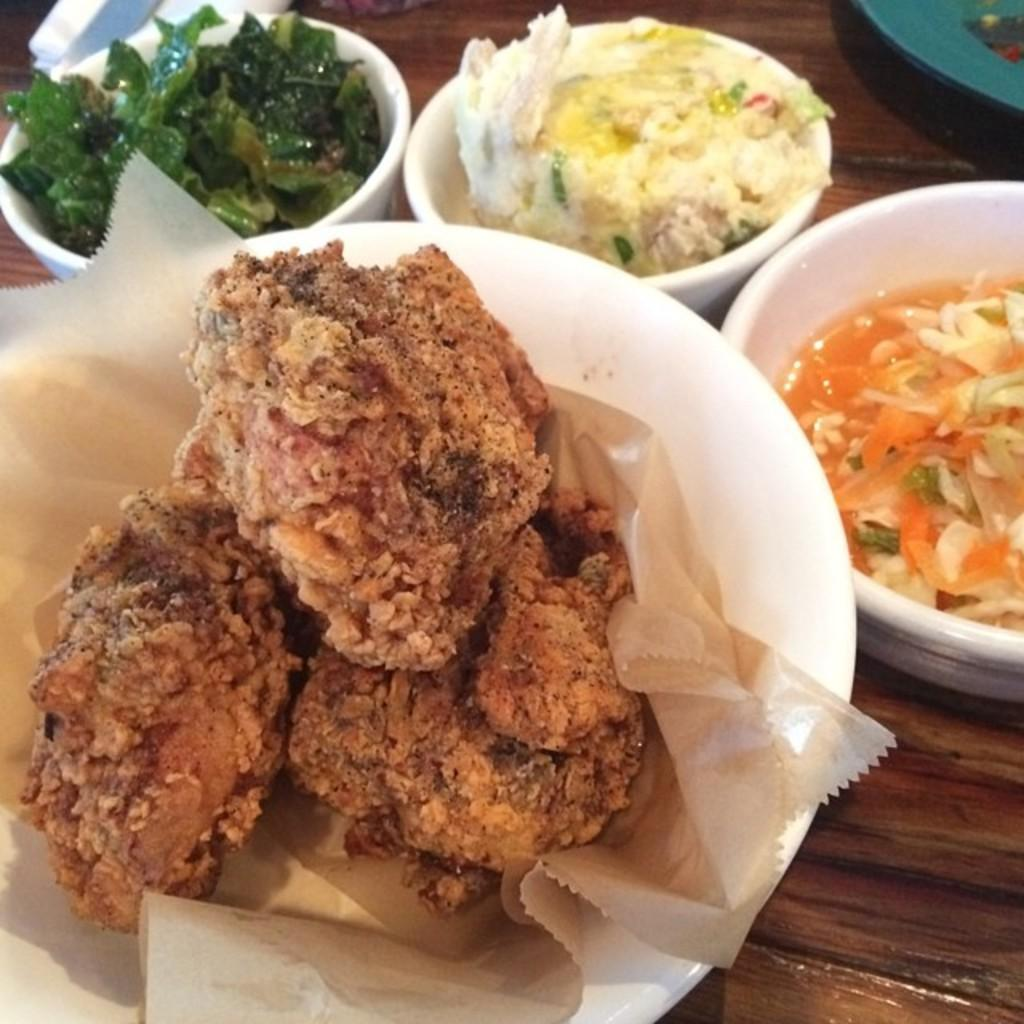How many bowls with food items are visible in the image? There are four bowls with food items in the image. What other items can be seen in the image besides the bowls? There is a paper, a plate, and an object in the image. Where are these items placed? All of these items are placed on a wooden table. Are there any collars visible on the food items in the image? No, there are no collars present in the image, as collars are typically associated with animals and not food items. 